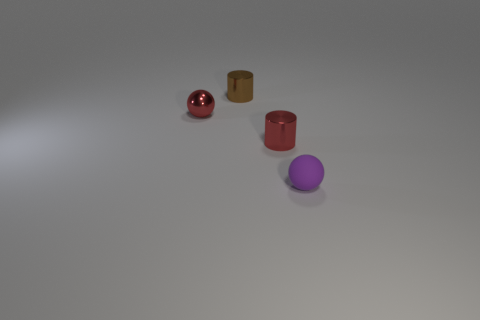There is a small cylinder that is the same color as the metallic ball; what is its material?
Offer a very short reply. Metal. There is a tiny cylinder that is in front of the red metallic sphere; does it have the same color as the small metallic sphere?
Give a very brief answer. Yes. There is another small thing that is the same shape as the small brown thing; what color is it?
Keep it short and to the point. Red. What is the tiny purple thing made of?
Your answer should be very brief. Rubber. What color is the tiny cylinder in front of the brown metallic object?
Ensure brevity in your answer.  Red. How many big things are either purple rubber balls or balls?
Your response must be concise. 0. There is a small ball that is behind the small purple rubber sphere; does it have the same color as the metal cylinder that is to the right of the tiny brown metal thing?
Your answer should be compact. Yes. How many other objects are the same color as the tiny shiny sphere?
Your response must be concise. 1. How many red objects are balls or tiny metal cylinders?
Provide a succinct answer. 2. Do the tiny matte thing and the red metal thing behind the red metallic cylinder have the same shape?
Offer a terse response. Yes. 